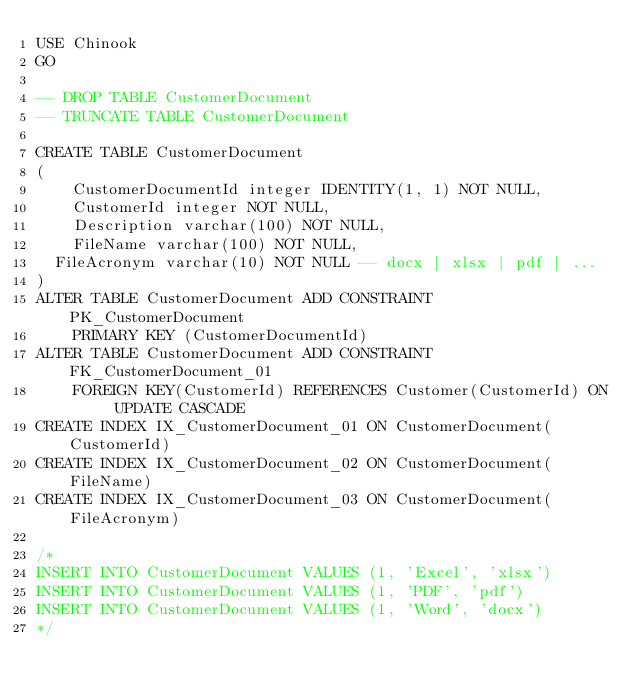Convert code to text. <code><loc_0><loc_0><loc_500><loc_500><_SQL_>USE Chinook
GO

-- DROP TABLE CustomerDocument
-- TRUNCATE TABLE CustomerDocument

CREATE TABLE CustomerDocument
(
    CustomerDocumentId integer IDENTITY(1, 1) NOT NULL, 
    CustomerId integer NOT NULL, 
    Description varchar(100) NOT NULL,
    FileName varchar(100) NOT NULL,
	FileAcronym varchar(10) NOT NULL -- docx | xlsx | pdf | ...
)
ALTER TABLE CustomerDocument ADD CONSTRAINT PK_CustomerDocument
    PRIMARY KEY (CustomerDocumentId)
ALTER TABLE CustomerDocument ADD CONSTRAINT FK_CustomerDocument_01
    FOREIGN KEY(CustomerId) REFERENCES Customer(CustomerId) ON UPDATE CASCADE
CREATE INDEX IX_CustomerDocument_01 ON CustomerDocument(CustomerId)
CREATE INDEX IX_CustomerDocument_02 ON CustomerDocument(FileName)
CREATE INDEX IX_CustomerDocument_03 ON CustomerDocument(FileAcronym)

/*
INSERT INTO CustomerDocument VALUES (1, 'Excel', 'xlsx')
INSERT INTO CustomerDocument VALUES (1, 'PDF', 'pdf')
INSERT INTO CustomerDocument VALUES (1, 'Word', 'docx')
*/
</code> 